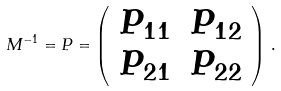<formula> <loc_0><loc_0><loc_500><loc_500>M ^ { - 1 } = P = \left ( \begin{array} { c c } P _ { 1 1 } & P _ { 1 2 } \\ P _ { 2 1 } & P _ { 2 2 } \end{array} \right ) \, .</formula> 